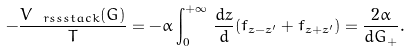Convert formula to latex. <formula><loc_0><loc_0><loc_500><loc_500>- \frac { V _ { \ r s s s t a c k } ( G ) } { T } & = - \bar { \alpha } \int _ { 0 } ^ { + \infty } \, \frac { d z } { d } ( \bar { f } _ { z - z ^ { \prime } } + \bar { f } _ { z + z ^ { \prime } } ) = \frac { 2 \bar { \alpha } } { d G _ { + } } .</formula> 